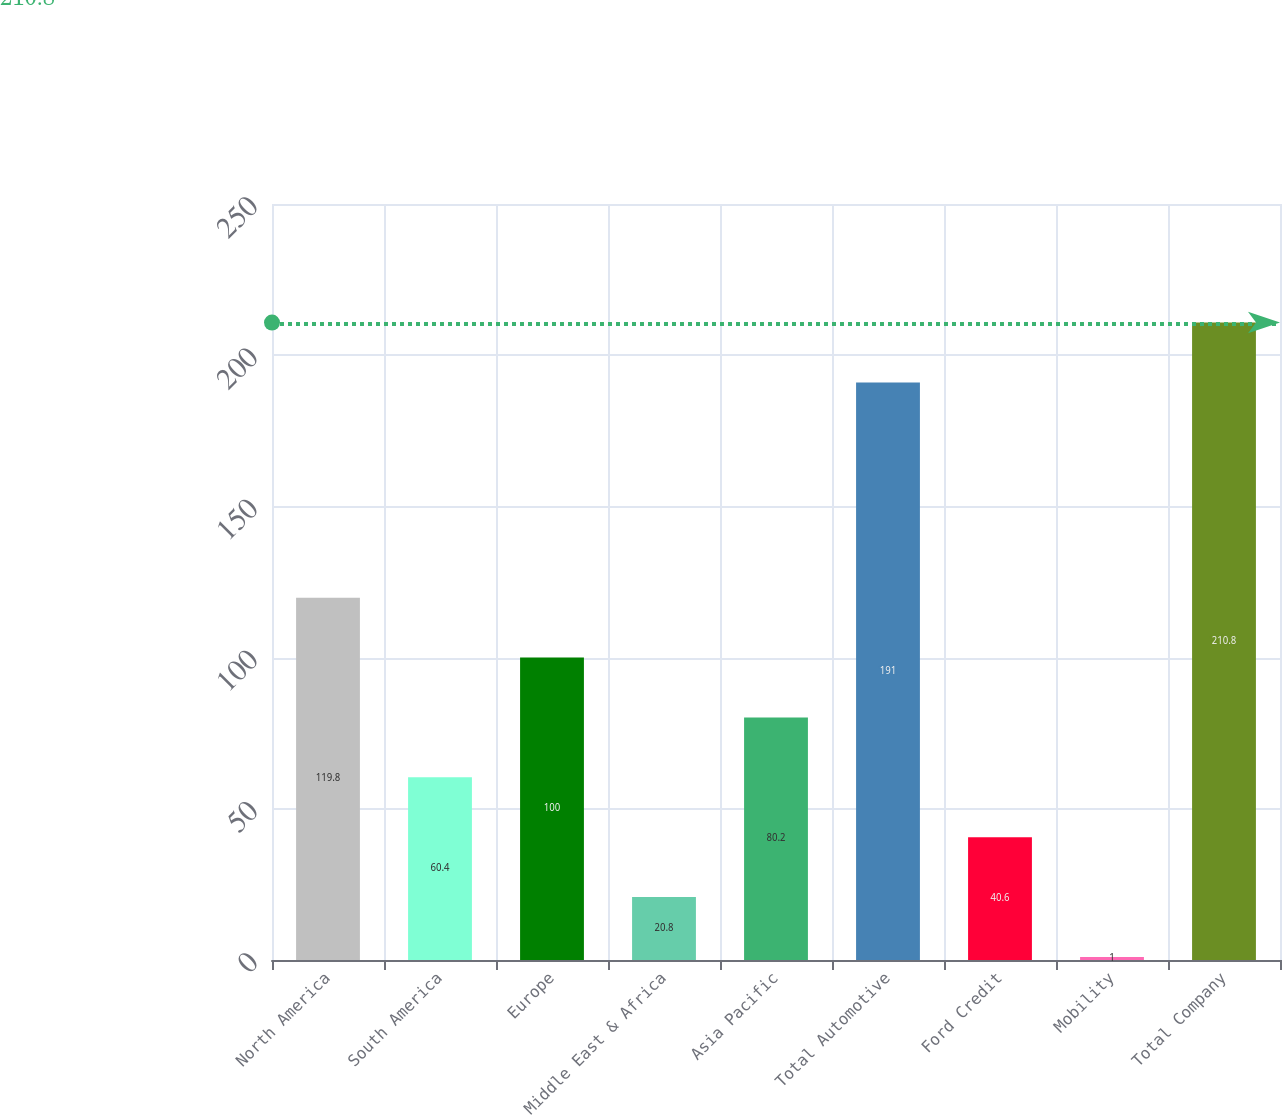<chart> <loc_0><loc_0><loc_500><loc_500><bar_chart><fcel>North America<fcel>South America<fcel>Europe<fcel>Middle East & Africa<fcel>Asia Pacific<fcel>Total Automotive<fcel>Ford Credit<fcel>Mobility<fcel>Total Company<nl><fcel>119.8<fcel>60.4<fcel>100<fcel>20.8<fcel>80.2<fcel>191<fcel>40.6<fcel>1<fcel>210.8<nl></chart> 